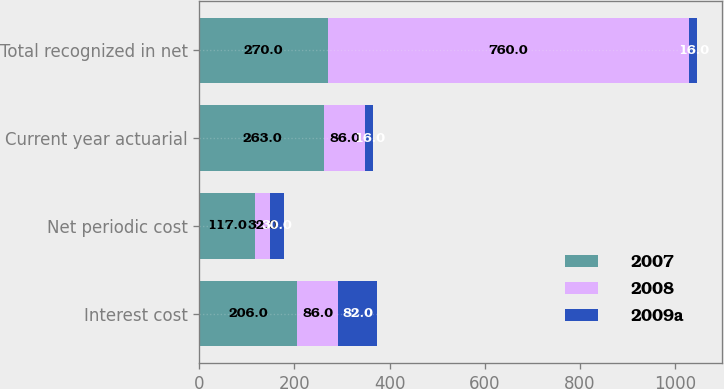Convert chart to OTSL. <chart><loc_0><loc_0><loc_500><loc_500><stacked_bar_chart><ecel><fcel>Interest cost<fcel>Net periodic cost<fcel>Current year actuarial<fcel>Total recognized in net<nl><fcel>2007<fcel>206<fcel>117<fcel>263<fcel>270<nl><fcel>2008<fcel>86<fcel>32<fcel>86<fcel>760<nl><fcel>2009a<fcel>82<fcel>30<fcel>16<fcel>16<nl></chart> 